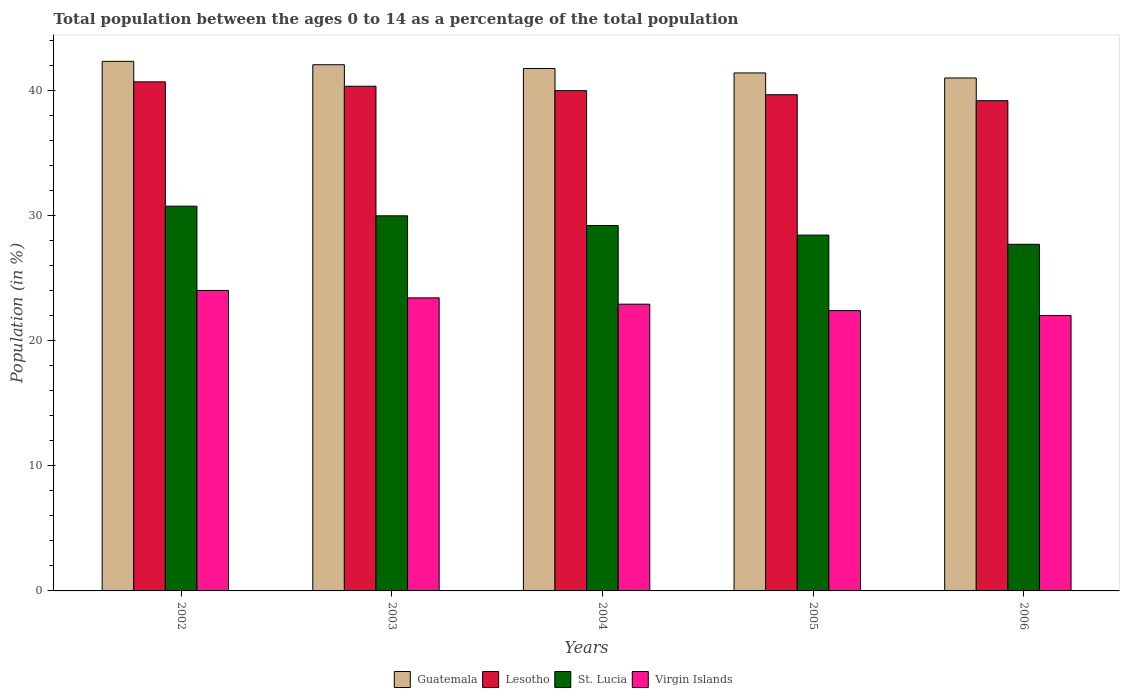How many different coloured bars are there?
Keep it short and to the point. 4. How many bars are there on the 2nd tick from the right?
Offer a terse response. 4. What is the label of the 2nd group of bars from the left?
Your answer should be compact. 2003. What is the percentage of the population ages 0 to 14 in St. Lucia in 2006?
Keep it short and to the point. 27.72. Across all years, what is the maximum percentage of the population ages 0 to 14 in Guatemala?
Make the answer very short. 42.35. Across all years, what is the minimum percentage of the population ages 0 to 14 in Lesotho?
Provide a succinct answer. 39.21. What is the total percentage of the population ages 0 to 14 in Virgin Islands in the graph?
Provide a short and direct response. 114.85. What is the difference between the percentage of the population ages 0 to 14 in Guatemala in 2002 and that in 2004?
Offer a very short reply. 0.57. What is the difference between the percentage of the population ages 0 to 14 in Virgin Islands in 2003 and the percentage of the population ages 0 to 14 in St. Lucia in 2002?
Keep it short and to the point. -7.33. What is the average percentage of the population ages 0 to 14 in Guatemala per year?
Keep it short and to the point. 41.73. In the year 2006, what is the difference between the percentage of the population ages 0 to 14 in Guatemala and percentage of the population ages 0 to 14 in St. Lucia?
Give a very brief answer. 13.3. In how many years, is the percentage of the population ages 0 to 14 in St. Lucia greater than 32?
Your response must be concise. 0. What is the ratio of the percentage of the population ages 0 to 14 in St. Lucia in 2003 to that in 2006?
Give a very brief answer. 1.08. Is the percentage of the population ages 0 to 14 in Guatemala in 2003 less than that in 2006?
Make the answer very short. No. Is the difference between the percentage of the population ages 0 to 14 in Guatemala in 2004 and 2006 greater than the difference between the percentage of the population ages 0 to 14 in St. Lucia in 2004 and 2006?
Your answer should be very brief. No. What is the difference between the highest and the second highest percentage of the population ages 0 to 14 in Guatemala?
Your response must be concise. 0.27. What is the difference between the highest and the lowest percentage of the population ages 0 to 14 in Virgin Islands?
Keep it short and to the point. 2.01. Is the sum of the percentage of the population ages 0 to 14 in St. Lucia in 2004 and 2005 greater than the maximum percentage of the population ages 0 to 14 in Lesotho across all years?
Provide a succinct answer. Yes. Is it the case that in every year, the sum of the percentage of the population ages 0 to 14 in St. Lucia and percentage of the population ages 0 to 14 in Lesotho is greater than the sum of percentage of the population ages 0 to 14 in Guatemala and percentage of the population ages 0 to 14 in Virgin Islands?
Offer a very short reply. Yes. What does the 1st bar from the left in 2003 represents?
Give a very brief answer. Guatemala. What does the 2nd bar from the right in 2004 represents?
Make the answer very short. St. Lucia. How many bars are there?
Offer a very short reply. 20. Does the graph contain any zero values?
Provide a succinct answer. No. Where does the legend appear in the graph?
Provide a succinct answer. Bottom center. How many legend labels are there?
Ensure brevity in your answer.  4. What is the title of the graph?
Keep it short and to the point. Total population between the ages 0 to 14 as a percentage of the total population. What is the label or title of the Y-axis?
Provide a succinct answer. Population (in %). What is the Population (in %) of Guatemala in 2002?
Your answer should be very brief. 42.35. What is the Population (in %) in Lesotho in 2002?
Offer a terse response. 40.72. What is the Population (in %) in St. Lucia in 2002?
Ensure brevity in your answer.  30.77. What is the Population (in %) in Virgin Islands in 2002?
Offer a terse response. 24.03. What is the Population (in %) of Guatemala in 2003?
Provide a short and direct response. 42.08. What is the Population (in %) in Lesotho in 2003?
Your answer should be compact. 40.36. What is the Population (in %) of St. Lucia in 2003?
Offer a very short reply. 30. What is the Population (in %) in Virgin Islands in 2003?
Your response must be concise. 23.44. What is the Population (in %) in Guatemala in 2004?
Your answer should be compact. 41.78. What is the Population (in %) of Lesotho in 2004?
Provide a succinct answer. 40.01. What is the Population (in %) of St. Lucia in 2004?
Make the answer very short. 29.22. What is the Population (in %) of Virgin Islands in 2004?
Give a very brief answer. 22.93. What is the Population (in %) in Guatemala in 2005?
Your answer should be very brief. 41.43. What is the Population (in %) of Lesotho in 2005?
Offer a very short reply. 39.68. What is the Population (in %) of St. Lucia in 2005?
Offer a terse response. 28.46. What is the Population (in %) in Virgin Islands in 2005?
Provide a short and direct response. 22.42. What is the Population (in %) in Guatemala in 2006?
Provide a succinct answer. 41.02. What is the Population (in %) in Lesotho in 2006?
Make the answer very short. 39.21. What is the Population (in %) in St. Lucia in 2006?
Keep it short and to the point. 27.72. What is the Population (in %) of Virgin Islands in 2006?
Offer a terse response. 22.03. Across all years, what is the maximum Population (in %) of Guatemala?
Your answer should be very brief. 42.35. Across all years, what is the maximum Population (in %) of Lesotho?
Provide a short and direct response. 40.72. Across all years, what is the maximum Population (in %) of St. Lucia?
Provide a short and direct response. 30.77. Across all years, what is the maximum Population (in %) in Virgin Islands?
Ensure brevity in your answer.  24.03. Across all years, what is the minimum Population (in %) in Guatemala?
Give a very brief answer. 41.02. Across all years, what is the minimum Population (in %) of Lesotho?
Your response must be concise. 39.21. Across all years, what is the minimum Population (in %) in St. Lucia?
Your answer should be compact. 27.72. Across all years, what is the minimum Population (in %) in Virgin Islands?
Provide a succinct answer. 22.03. What is the total Population (in %) of Guatemala in the graph?
Offer a very short reply. 208.67. What is the total Population (in %) in Lesotho in the graph?
Ensure brevity in your answer.  199.98. What is the total Population (in %) in St. Lucia in the graph?
Make the answer very short. 146.18. What is the total Population (in %) in Virgin Islands in the graph?
Offer a very short reply. 114.85. What is the difference between the Population (in %) of Guatemala in 2002 and that in 2003?
Give a very brief answer. 0.27. What is the difference between the Population (in %) of Lesotho in 2002 and that in 2003?
Offer a very short reply. 0.35. What is the difference between the Population (in %) of St. Lucia in 2002 and that in 2003?
Your answer should be very brief. 0.77. What is the difference between the Population (in %) in Virgin Islands in 2002 and that in 2003?
Provide a short and direct response. 0.59. What is the difference between the Population (in %) in Guatemala in 2002 and that in 2004?
Provide a short and direct response. 0.57. What is the difference between the Population (in %) in Lesotho in 2002 and that in 2004?
Your answer should be compact. 0.71. What is the difference between the Population (in %) in St. Lucia in 2002 and that in 2004?
Your response must be concise. 1.55. What is the difference between the Population (in %) in Virgin Islands in 2002 and that in 2004?
Your answer should be very brief. 1.1. What is the difference between the Population (in %) of Guatemala in 2002 and that in 2005?
Give a very brief answer. 0.93. What is the difference between the Population (in %) in Lesotho in 2002 and that in 2005?
Offer a very short reply. 1.03. What is the difference between the Population (in %) in St. Lucia in 2002 and that in 2005?
Your response must be concise. 2.31. What is the difference between the Population (in %) in Virgin Islands in 2002 and that in 2005?
Your response must be concise. 1.61. What is the difference between the Population (in %) in Guatemala in 2002 and that in 2006?
Ensure brevity in your answer.  1.33. What is the difference between the Population (in %) of Lesotho in 2002 and that in 2006?
Provide a short and direct response. 1.51. What is the difference between the Population (in %) of St. Lucia in 2002 and that in 2006?
Provide a succinct answer. 3.05. What is the difference between the Population (in %) in Virgin Islands in 2002 and that in 2006?
Offer a very short reply. 2.01. What is the difference between the Population (in %) of Guatemala in 2003 and that in 2004?
Give a very brief answer. 0.3. What is the difference between the Population (in %) of Lesotho in 2003 and that in 2004?
Keep it short and to the point. 0.35. What is the difference between the Population (in %) in St. Lucia in 2003 and that in 2004?
Offer a terse response. 0.78. What is the difference between the Population (in %) of Virgin Islands in 2003 and that in 2004?
Your response must be concise. 0.5. What is the difference between the Population (in %) of Guatemala in 2003 and that in 2005?
Your response must be concise. 0.66. What is the difference between the Population (in %) in Lesotho in 2003 and that in 2005?
Provide a short and direct response. 0.68. What is the difference between the Population (in %) in St. Lucia in 2003 and that in 2005?
Your answer should be compact. 1.54. What is the difference between the Population (in %) in Virgin Islands in 2003 and that in 2005?
Offer a terse response. 1.02. What is the difference between the Population (in %) of Guatemala in 2003 and that in 2006?
Offer a very short reply. 1.06. What is the difference between the Population (in %) in Lesotho in 2003 and that in 2006?
Your answer should be compact. 1.16. What is the difference between the Population (in %) of St. Lucia in 2003 and that in 2006?
Your answer should be compact. 2.28. What is the difference between the Population (in %) of Virgin Islands in 2003 and that in 2006?
Your answer should be compact. 1.41. What is the difference between the Population (in %) in Guatemala in 2004 and that in 2005?
Provide a short and direct response. 0.35. What is the difference between the Population (in %) in Lesotho in 2004 and that in 2005?
Provide a short and direct response. 0.33. What is the difference between the Population (in %) of St. Lucia in 2004 and that in 2005?
Your answer should be very brief. 0.77. What is the difference between the Population (in %) in Virgin Islands in 2004 and that in 2005?
Provide a short and direct response. 0.51. What is the difference between the Population (in %) of Guatemala in 2004 and that in 2006?
Provide a succinct answer. 0.76. What is the difference between the Population (in %) of Lesotho in 2004 and that in 2006?
Offer a terse response. 0.8. What is the difference between the Population (in %) of St. Lucia in 2004 and that in 2006?
Ensure brevity in your answer.  1.5. What is the difference between the Population (in %) of Virgin Islands in 2004 and that in 2006?
Make the answer very short. 0.91. What is the difference between the Population (in %) in Guatemala in 2005 and that in 2006?
Your response must be concise. 0.4. What is the difference between the Population (in %) in Lesotho in 2005 and that in 2006?
Keep it short and to the point. 0.48. What is the difference between the Population (in %) of St. Lucia in 2005 and that in 2006?
Provide a succinct answer. 0.74. What is the difference between the Population (in %) in Virgin Islands in 2005 and that in 2006?
Ensure brevity in your answer.  0.39. What is the difference between the Population (in %) in Guatemala in 2002 and the Population (in %) in Lesotho in 2003?
Your response must be concise. 1.99. What is the difference between the Population (in %) of Guatemala in 2002 and the Population (in %) of St. Lucia in 2003?
Offer a terse response. 12.35. What is the difference between the Population (in %) of Guatemala in 2002 and the Population (in %) of Virgin Islands in 2003?
Provide a short and direct response. 18.92. What is the difference between the Population (in %) in Lesotho in 2002 and the Population (in %) in St. Lucia in 2003?
Your answer should be very brief. 10.72. What is the difference between the Population (in %) in Lesotho in 2002 and the Population (in %) in Virgin Islands in 2003?
Keep it short and to the point. 17.28. What is the difference between the Population (in %) of St. Lucia in 2002 and the Population (in %) of Virgin Islands in 2003?
Keep it short and to the point. 7.33. What is the difference between the Population (in %) of Guatemala in 2002 and the Population (in %) of Lesotho in 2004?
Ensure brevity in your answer.  2.34. What is the difference between the Population (in %) in Guatemala in 2002 and the Population (in %) in St. Lucia in 2004?
Provide a succinct answer. 13.13. What is the difference between the Population (in %) in Guatemala in 2002 and the Population (in %) in Virgin Islands in 2004?
Offer a very short reply. 19.42. What is the difference between the Population (in %) in Lesotho in 2002 and the Population (in %) in St. Lucia in 2004?
Your answer should be compact. 11.49. What is the difference between the Population (in %) of Lesotho in 2002 and the Population (in %) of Virgin Islands in 2004?
Offer a very short reply. 17.78. What is the difference between the Population (in %) of St. Lucia in 2002 and the Population (in %) of Virgin Islands in 2004?
Offer a terse response. 7.84. What is the difference between the Population (in %) of Guatemala in 2002 and the Population (in %) of Lesotho in 2005?
Ensure brevity in your answer.  2.67. What is the difference between the Population (in %) of Guatemala in 2002 and the Population (in %) of St. Lucia in 2005?
Give a very brief answer. 13.9. What is the difference between the Population (in %) in Guatemala in 2002 and the Population (in %) in Virgin Islands in 2005?
Give a very brief answer. 19.94. What is the difference between the Population (in %) of Lesotho in 2002 and the Population (in %) of St. Lucia in 2005?
Offer a terse response. 12.26. What is the difference between the Population (in %) of Lesotho in 2002 and the Population (in %) of Virgin Islands in 2005?
Give a very brief answer. 18.3. What is the difference between the Population (in %) in St. Lucia in 2002 and the Population (in %) in Virgin Islands in 2005?
Keep it short and to the point. 8.35. What is the difference between the Population (in %) of Guatemala in 2002 and the Population (in %) of Lesotho in 2006?
Keep it short and to the point. 3.15. What is the difference between the Population (in %) of Guatemala in 2002 and the Population (in %) of St. Lucia in 2006?
Your answer should be compact. 14.63. What is the difference between the Population (in %) in Guatemala in 2002 and the Population (in %) in Virgin Islands in 2006?
Offer a very short reply. 20.33. What is the difference between the Population (in %) in Lesotho in 2002 and the Population (in %) in St. Lucia in 2006?
Give a very brief answer. 12.99. What is the difference between the Population (in %) in Lesotho in 2002 and the Population (in %) in Virgin Islands in 2006?
Make the answer very short. 18.69. What is the difference between the Population (in %) in St. Lucia in 2002 and the Population (in %) in Virgin Islands in 2006?
Your response must be concise. 8.74. What is the difference between the Population (in %) of Guatemala in 2003 and the Population (in %) of Lesotho in 2004?
Provide a short and direct response. 2.07. What is the difference between the Population (in %) of Guatemala in 2003 and the Population (in %) of St. Lucia in 2004?
Offer a very short reply. 12.86. What is the difference between the Population (in %) of Guatemala in 2003 and the Population (in %) of Virgin Islands in 2004?
Offer a terse response. 19.15. What is the difference between the Population (in %) in Lesotho in 2003 and the Population (in %) in St. Lucia in 2004?
Your answer should be compact. 11.14. What is the difference between the Population (in %) of Lesotho in 2003 and the Population (in %) of Virgin Islands in 2004?
Ensure brevity in your answer.  17.43. What is the difference between the Population (in %) in St. Lucia in 2003 and the Population (in %) in Virgin Islands in 2004?
Provide a short and direct response. 7.07. What is the difference between the Population (in %) in Guatemala in 2003 and the Population (in %) in Lesotho in 2005?
Provide a succinct answer. 2.4. What is the difference between the Population (in %) in Guatemala in 2003 and the Population (in %) in St. Lucia in 2005?
Offer a very short reply. 13.62. What is the difference between the Population (in %) in Guatemala in 2003 and the Population (in %) in Virgin Islands in 2005?
Ensure brevity in your answer.  19.67. What is the difference between the Population (in %) in Lesotho in 2003 and the Population (in %) in St. Lucia in 2005?
Ensure brevity in your answer.  11.9. What is the difference between the Population (in %) in Lesotho in 2003 and the Population (in %) in Virgin Islands in 2005?
Your answer should be compact. 17.95. What is the difference between the Population (in %) of St. Lucia in 2003 and the Population (in %) of Virgin Islands in 2005?
Provide a short and direct response. 7.58. What is the difference between the Population (in %) of Guatemala in 2003 and the Population (in %) of Lesotho in 2006?
Give a very brief answer. 2.88. What is the difference between the Population (in %) of Guatemala in 2003 and the Population (in %) of St. Lucia in 2006?
Make the answer very short. 14.36. What is the difference between the Population (in %) of Guatemala in 2003 and the Population (in %) of Virgin Islands in 2006?
Make the answer very short. 20.06. What is the difference between the Population (in %) in Lesotho in 2003 and the Population (in %) in St. Lucia in 2006?
Offer a terse response. 12.64. What is the difference between the Population (in %) in Lesotho in 2003 and the Population (in %) in Virgin Islands in 2006?
Make the answer very short. 18.34. What is the difference between the Population (in %) in St. Lucia in 2003 and the Population (in %) in Virgin Islands in 2006?
Your answer should be compact. 7.97. What is the difference between the Population (in %) of Guatemala in 2004 and the Population (in %) of Lesotho in 2005?
Your answer should be very brief. 2.1. What is the difference between the Population (in %) in Guatemala in 2004 and the Population (in %) in St. Lucia in 2005?
Ensure brevity in your answer.  13.32. What is the difference between the Population (in %) in Guatemala in 2004 and the Population (in %) in Virgin Islands in 2005?
Provide a short and direct response. 19.36. What is the difference between the Population (in %) of Lesotho in 2004 and the Population (in %) of St. Lucia in 2005?
Provide a short and direct response. 11.55. What is the difference between the Population (in %) of Lesotho in 2004 and the Population (in %) of Virgin Islands in 2005?
Provide a succinct answer. 17.59. What is the difference between the Population (in %) of St. Lucia in 2004 and the Population (in %) of Virgin Islands in 2005?
Provide a short and direct response. 6.81. What is the difference between the Population (in %) in Guatemala in 2004 and the Population (in %) in Lesotho in 2006?
Make the answer very short. 2.57. What is the difference between the Population (in %) of Guatemala in 2004 and the Population (in %) of St. Lucia in 2006?
Offer a very short reply. 14.06. What is the difference between the Population (in %) of Guatemala in 2004 and the Population (in %) of Virgin Islands in 2006?
Provide a short and direct response. 19.75. What is the difference between the Population (in %) in Lesotho in 2004 and the Population (in %) in St. Lucia in 2006?
Keep it short and to the point. 12.29. What is the difference between the Population (in %) in Lesotho in 2004 and the Population (in %) in Virgin Islands in 2006?
Offer a very short reply. 17.98. What is the difference between the Population (in %) of St. Lucia in 2004 and the Population (in %) of Virgin Islands in 2006?
Your answer should be compact. 7.2. What is the difference between the Population (in %) in Guatemala in 2005 and the Population (in %) in Lesotho in 2006?
Give a very brief answer. 2.22. What is the difference between the Population (in %) in Guatemala in 2005 and the Population (in %) in St. Lucia in 2006?
Give a very brief answer. 13.7. What is the difference between the Population (in %) of Guatemala in 2005 and the Population (in %) of Virgin Islands in 2006?
Offer a very short reply. 19.4. What is the difference between the Population (in %) of Lesotho in 2005 and the Population (in %) of St. Lucia in 2006?
Ensure brevity in your answer.  11.96. What is the difference between the Population (in %) in Lesotho in 2005 and the Population (in %) in Virgin Islands in 2006?
Ensure brevity in your answer.  17.66. What is the difference between the Population (in %) of St. Lucia in 2005 and the Population (in %) of Virgin Islands in 2006?
Your answer should be compact. 6.43. What is the average Population (in %) in Guatemala per year?
Your answer should be compact. 41.73. What is the average Population (in %) in Lesotho per year?
Offer a terse response. 40. What is the average Population (in %) of St. Lucia per year?
Keep it short and to the point. 29.24. What is the average Population (in %) in Virgin Islands per year?
Your response must be concise. 22.97. In the year 2002, what is the difference between the Population (in %) of Guatemala and Population (in %) of Lesotho?
Your response must be concise. 1.64. In the year 2002, what is the difference between the Population (in %) in Guatemala and Population (in %) in St. Lucia?
Ensure brevity in your answer.  11.58. In the year 2002, what is the difference between the Population (in %) in Guatemala and Population (in %) in Virgin Islands?
Keep it short and to the point. 18.32. In the year 2002, what is the difference between the Population (in %) in Lesotho and Population (in %) in St. Lucia?
Ensure brevity in your answer.  9.95. In the year 2002, what is the difference between the Population (in %) of Lesotho and Population (in %) of Virgin Islands?
Offer a terse response. 16.68. In the year 2002, what is the difference between the Population (in %) of St. Lucia and Population (in %) of Virgin Islands?
Ensure brevity in your answer.  6.74. In the year 2003, what is the difference between the Population (in %) of Guatemala and Population (in %) of Lesotho?
Your response must be concise. 1.72. In the year 2003, what is the difference between the Population (in %) of Guatemala and Population (in %) of St. Lucia?
Your response must be concise. 12.08. In the year 2003, what is the difference between the Population (in %) in Guatemala and Population (in %) in Virgin Islands?
Your answer should be very brief. 18.65. In the year 2003, what is the difference between the Population (in %) of Lesotho and Population (in %) of St. Lucia?
Offer a terse response. 10.36. In the year 2003, what is the difference between the Population (in %) of Lesotho and Population (in %) of Virgin Islands?
Keep it short and to the point. 16.93. In the year 2003, what is the difference between the Population (in %) in St. Lucia and Population (in %) in Virgin Islands?
Offer a terse response. 6.56. In the year 2004, what is the difference between the Population (in %) in Guatemala and Population (in %) in Lesotho?
Your response must be concise. 1.77. In the year 2004, what is the difference between the Population (in %) of Guatemala and Population (in %) of St. Lucia?
Keep it short and to the point. 12.56. In the year 2004, what is the difference between the Population (in %) of Guatemala and Population (in %) of Virgin Islands?
Ensure brevity in your answer.  18.85. In the year 2004, what is the difference between the Population (in %) of Lesotho and Population (in %) of St. Lucia?
Give a very brief answer. 10.79. In the year 2004, what is the difference between the Population (in %) of Lesotho and Population (in %) of Virgin Islands?
Your response must be concise. 17.08. In the year 2004, what is the difference between the Population (in %) of St. Lucia and Population (in %) of Virgin Islands?
Provide a succinct answer. 6.29. In the year 2005, what is the difference between the Population (in %) in Guatemala and Population (in %) in Lesotho?
Your answer should be very brief. 1.74. In the year 2005, what is the difference between the Population (in %) in Guatemala and Population (in %) in St. Lucia?
Ensure brevity in your answer.  12.97. In the year 2005, what is the difference between the Population (in %) in Guatemala and Population (in %) in Virgin Islands?
Your answer should be compact. 19.01. In the year 2005, what is the difference between the Population (in %) in Lesotho and Population (in %) in St. Lucia?
Give a very brief answer. 11.22. In the year 2005, what is the difference between the Population (in %) in Lesotho and Population (in %) in Virgin Islands?
Give a very brief answer. 17.27. In the year 2005, what is the difference between the Population (in %) of St. Lucia and Population (in %) of Virgin Islands?
Your answer should be compact. 6.04. In the year 2006, what is the difference between the Population (in %) in Guatemala and Population (in %) in Lesotho?
Provide a short and direct response. 1.82. In the year 2006, what is the difference between the Population (in %) of Guatemala and Population (in %) of St. Lucia?
Give a very brief answer. 13.3. In the year 2006, what is the difference between the Population (in %) of Guatemala and Population (in %) of Virgin Islands?
Your response must be concise. 19. In the year 2006, what is the difference between the Population (in %) of Lesotho and Population (in %) of St. Lucia?
Give a very brief answer. 11.49. In the year 2006, what is the difference between the Population (in %) in Lesotho and Population (in %) in Virgin Islands?
Provide a succinct answer. 17.18. In the year 2006, what is the difference between the Population (in %) in St. Lucia and Population (in %) in Virgin Islands?
Offer a terse response. 5.7. What is the ratio of the Population (in %) in Guatemala in 2002 to that in 2003?
Offer a very short reply. 1.01. What is the ratio of the Population (in %) in Lesotho in 2002 to that in 2003?
Your response must be concise. 1.01. What is the ratio of the Population (in %) of St. Lucia in 2002 to that in 2003?
Keep it short and to the point. 1.03. What is the ratio of the Population (in %) of Virgin Islands in 2002 to that in 2003?
Your answer should be compact. 1.03. What is the ratio of the Population (in %) in Guatemala in 2002 to that in 2004?
Your response must be concise. 1.01. What is the ratio of the Population (in %) of Lesotho in 2002 to that in 2004?
Your answer should be compact. 1.02. What is the ratio of the Population (in %) in St. Lucia in 2002 to that in 2004?
Make the answer very short. 1.05. What is the ratio of the Population (in %) of Virgin Islands in 2002 to that in 2004?
Your response must be concise. 1.05. What is the ratio of the Population (in %) of Guatemala in 2002 to that in 2005?
Give a very brief answer. 1.02. What is the ratio of the Population (in %) of St. Lucia in 2002 to that in 2005?
Provide a succinct answer. 1.08. What is the ratio of the Population (in %) of Virgin Islands in 2002 to that in 2005?
Provide a short and direct response. 1.07. What is the ratio of the Population (in %) in Guatemala in 2002 to that in 2006?
Ensure brevity in your answer.  1.03. What is the ratio of the Population (in %) of Lesotho in 2002 to that in 2006?
Your response must be concise. 1.04. What is the ratio of the Population (in %) in St. Lucia in 2002 to that in 2006?
Ensure brevity in your answer.  1.11. What is the ratio of the Population (in %) in Virgin Islands in 2002 to that in 2006?
Offer a terse response. 1.09. What is the ratio of the Population (in %) in Lesotho in 2003 to that in 2004?
Keep it short and to the point. 1.01. What is the ratio of the Population (in %) in St. Lucia in 2003 to that in 2004?
Your answer should be very brief. 1.03. What is the ratio of the Population (in %) in Guatemala in 2003 to that in 2005?
Offer a very short reply. 1.02. What is the ratio of the Population (in %) of Lesotho in 2003 to that in 2005?
Keep it short and to the point. 1.02. What is the ratio of the Population (in %) in St. Lucia in 2003 to that in 2005?
Ensure brevity in your answer.  1.05. What is the ratio of the Population (in %) of Virgin Islands in 2003 to that in 2005?
Your answer should be very brief. 1.05. What is the ratio of the Population (in %) in Guatemala in 2003 to that in 2006?
Keep it short and to the point. 1.03. What is the ratio of the Population (in %) in Lesotho in 2003 to that in 2006?
Provide a succinct answer. 1.03. What is the ratio of the Population (in %) of St. Lucia in 2003 to that in 2006?
Your answer should be very brief. 1.08. What is the ratio of the Population (in %) of Virgin Islands in 2003 to that in 2006?
Make the answer very short. 1.06. What is the ratio of the Population (in %) of Guatemala in 2004 to that in 2005?
Your answer should be compact. 1.01. What is the ratio of the Population (in %) of Lesotho in 2004 to that in 2005?
Offer a very short reply. 1.01. What is the ratio of the Population (in %) of St. Lucia in 2004 to that in 2005?
Ensure brevity in your answer.  1.03. What is the ratio of the Population (in %) of Virgin Islands in 2004 to that in 2005?
Provide a succinct answer. 1.02. What is the ratio of the Population (in %) of Guatemala in 2004 to that in 2006?
Your response must be concise. 1.02. What is the ratio of the Population (in %) of Lesotho in 2004 to that in 2006?
Offer a very short reply. 1.02. What is the ratio of the Population (in %) in St. Lucia in 2004 to that in 2006?
Provide a short and direct response. 1.05. What is the ratio of the Population (in %) of Virgin Islands in 2004 to that in 2006?
Your response must be concise. 1.04. What is the ratio of the Population (in %) in Guatemala in 2005 to that in 2006?
Your response must be concise. 1.01. What is the ratio of the Population (in %) in Lesotho in 2005 to that in 2006?
Your answer should be compact. 1.01. What is the ratio of the Population (in %) in St. Lucia in 2005 to that in 2006?
Your answer should be very brief. 1.03. What is the ratio of the Population (in %) in Virgin Islands in 2005 to that in 2006?
Offer a very short reply. 1.02. What is the difference between the highest and the second highest Population (in %) of Guatemala?
Your answer should be very brief. 0.27. What is the difference between the highest and the second highest Population (in %) of Lesotho?
Provide a succinct answer. 0.35. What is the difference between the highest and the second highest Population (in %) in St. Lucia?
Provide a short and direct response. 0.77. What is the difference between the highest and the second highest Population (in %) in Virgin Islands?
Ensure brevity in your answer.  0.59. What is the difference between the highest and the lowest Population (in %) of Guatemala?
Your answer should be compact. 1.33. What is the difference between the highest and the lowest Population (in %) in Lesotho?
Ensure brevity in your answer.  1.51. What is the difference between the highest and the lowest Population (in %) in St. Lucia?
Your response must be concise. 3.05. What is the difference between the highest and the lowest Population (in %) in Virgin Islands?
Offer a terse response. 2.01. 